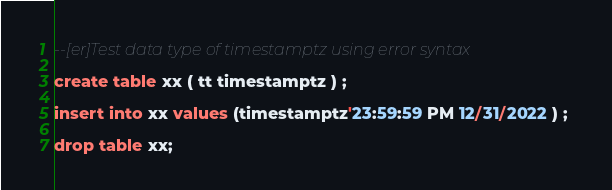Convert code to text. <code><loc_0><loc_0><loc_500><loc_500><_SQL_>--[er]Test data type of timestamptz using error syntax

create table xx ( tt timestamptz ) ; 

insert into xx values (timestamptz'23:59:59 PM 12/31/2022 ) ; 

drop table xx;
</code> 